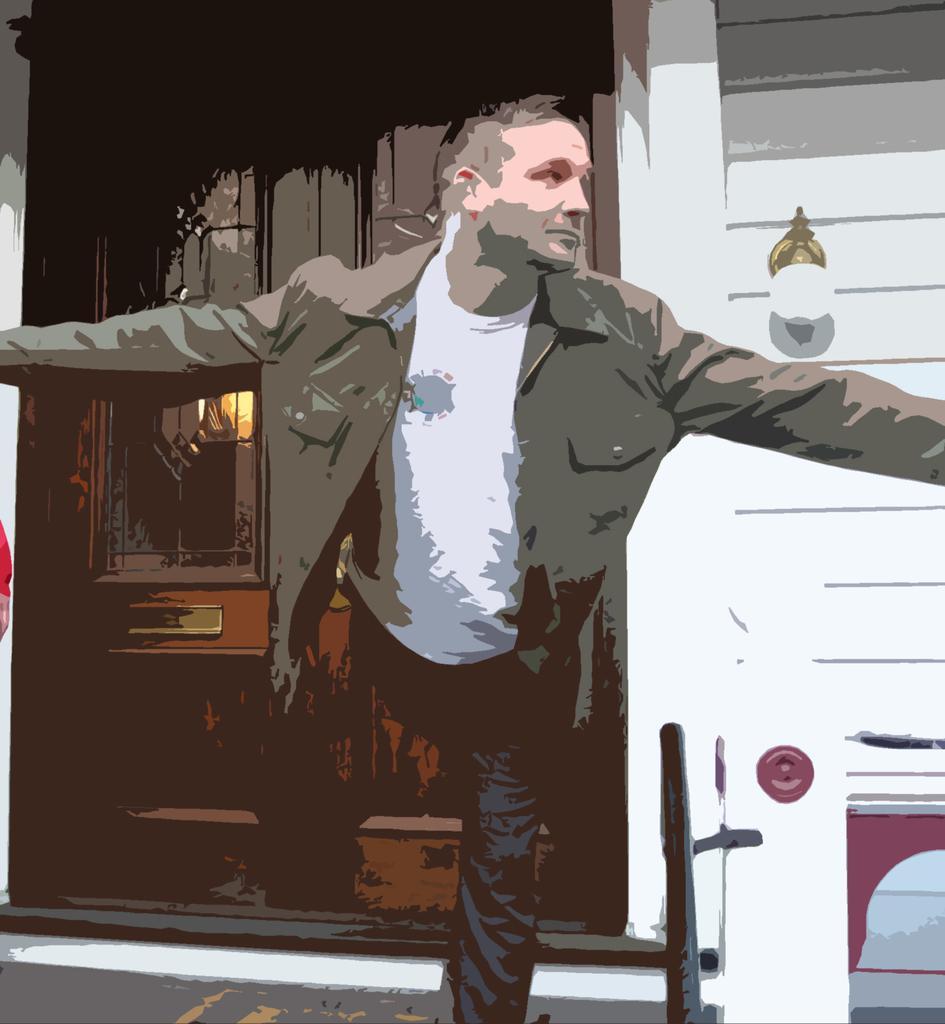Can you describe this image briefly? In this image I can see the person with the white t-shirt. To the side I can see the light to the wall. To the left I can see the door. 